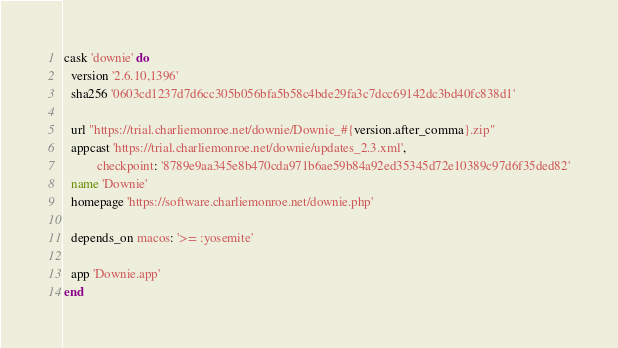Convert code to text. <code><loc_0><loc_0><loc_500><loc_500><_Ruby_>cask 'downie' do
  version '2.6.10,1396'
  sha256 '0603cd1237d7d6cc305b056bfa5b58c4bde29fa3c7dcc69142dc3bd40fc838d1'

  url "https://trial.charliemonroe.net/downie/Downie_#{version.after_comma}.zip"
  appcast 'https://trial.charliemonroe.net/downie/updates_2.3.xml',
          checkpoint: '8789e9aa345e8b470cda971b6ae59b84a92ed35345d72e10389c97d6f35ded82'
  name 'Downie'
  homepage 'https://software.charliemonroe.net/downie.php'

  depends_on macos: '>= :yosemite'

  app 'Downie.app'
end
</code> 